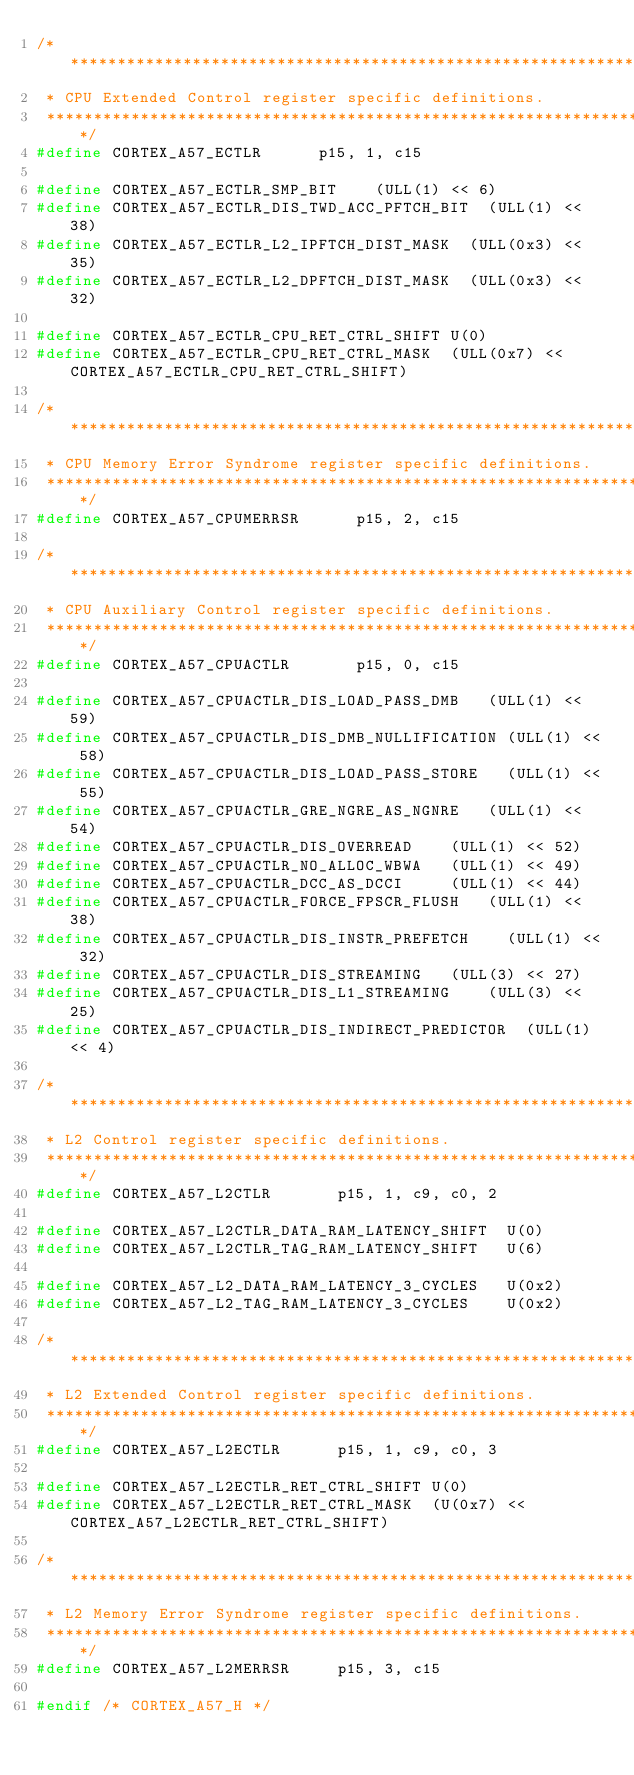Convert code to text. <code><loc_0><loc_0><loc_500><loc_500><_C_>/*******************************************************************************
 * CPU Extended Control register specific definitions.
 ******************************************************************************/
#define CORTEX_A57_ECTLR			p15, 1, c15

#define CORTEX_A57_ECTLR_SMP_BIT		(ULL(1) << 6)
#define CORTEX_A57_ECTLR_DIS_TWD_ACC_PFTCH_BIT	(ULL(1) << 38)
#define CORTEX_A57_ECTLR_L2_IPFTCH_DIST_MASK	(ULL(0x3) << 35)
#define CORTEX_A57_ECTLR_L2_DPFTCH_DIST_MASK	(ULL(0x3) << 32)

#define CORTEX_A57_ECTLR_CPU_RET_CTRL_SHIFT	U(0)
#define CORTEX_A57_ECTLR_CPU_RET_CTRL_MASK	(ULL(0x7) << CORTEX_A57_ECTLR_CPU_RET_CTRL_SHIFT)

/*******************************************************************************
 * CPU Memory Error Syndrome register specific definitions.
 ******************************************************************************/
#define CORTEX_A57_CPUMERRSR			p15, 2, c15

/*******************************************************************************
 * CPU Auxiliary Control register specific definitions.
 ******************************************************************************/
#define CORTEX_A57_CPUACTLR				p15, 0, c15

#define CORTEX_A57_CPUACTLR_DIS_LOAD_PASS_DMB		(ULL(1) << 59)
#define CORTEX_A57_CPUACTLR_DIS_DMB_NULLIFICATION	(ULL(1) << 58)
#define CORTEX_A57_CPUACTLR_DIS_LOAD_PASS_STORE		(ULL(1) << 55)
#define CORTEX_A57_CPUACTLR_GRE_NGRE_AS_NGNRE		(ULL(1) << 54)
#define CORTEX_A57_CPUACTLR_DIS_OVERREAD		(ULL(1) << 52)
#define CORTEX_A57_CPUACTLR_NO_ALLOC_WBWA		(ULL(1) << 49)
#define CORTEX_A57_CPUACTLR_DCC_AS_DCCI			(ULL(1) << 44)
#define CORTEX_A57_CPUACTLR_FORCE_FPSCR_FLUSH		(ULL(1) << 38)
#define CORTEX_A57_CPUACTLR_DIS_INSTR_PREFETCH		(ULL(1) << 32)
#define CORTEX_A57_CPUACTLR_DIS_STREAMING		(ULL(3) << 27)
#define CORTEX_A57_CPUACTLR_DIS_L1_STREAMING		(ULL(3) << 25)
#define CORTEX_A57_CPUACTLR_DIS_INDIRECT_PREDICTOR	(ULL(1) << 4)

/*******************************************************************************
 * L2 Control register specific definitions.
 ******************************************************************************/
#define CORTEX_A57_L2CTLR				p15, 1, c9, c0, 2

#define CORTEX_A57_L2CTLR_DATA_RAM_LATENCY_SHIFT	U(0)
#define CORTEX_A57_L2CTLR_TAG_RAM_LATENCY_SHIFT		U(6)

#define CORTEX_A57_L2_DATA_RAM_LATENCY_3_CYCLES		U(0x2)
#define CORTEX_A57_L2_TAG_RAM_LATENCY_3_CYCLES		U(0x2)

/*******************************************************************************
 * L2 Extended Control register specific definitions.
 ******************************************************************************/
#define CORTEX_A57_L2ECTLR			p15, 1, c9, c0, 3

#define CORTEX_A57_L2ECTLR_RET_CTRL_SHIFT	U(0)
#define CORTEX_A57_L2ECTLR_RET_CTRL_MASK	(U(0x7) << CORTEX_A57_L2ECTLR_RET_CTRL_SHIFT)

/*******************************************************************************
 * L2 Memory Error Syndrome register specific definitions.
 ******************************************************************************/
#define CORTEX_A57_L2MERRSR			p15, 3, c15

#endif /* CORTEX_A57_H */
</code> 